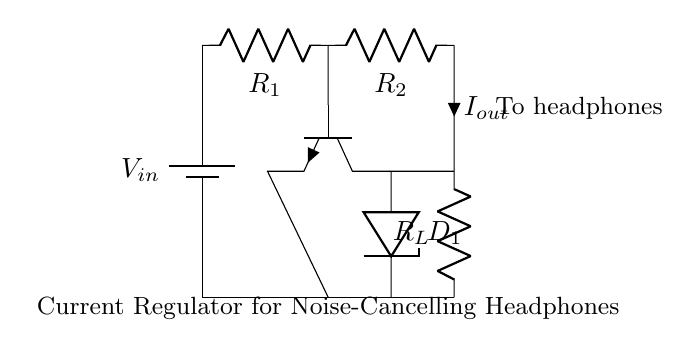What type of transistor is used in this circuit? The circuit contains an NPN transistor, as indicated by the symbol that represents a transistor with one arrow pointing out of the emitter, which is characteristic of NPN types.
Answer: NPN What is the function of the Zener diode in the circuit? The Zener diode is used to provide voltage regulation by maintaining a stable output voltage, effectively clamping the voltage to a certain level when the reverse bias exceeds the Zener breakdown voltage.
Answer: Voltage regulation How many resistors are in this circuit? There are three resistors labeled as R1, R2, and R_L in the circuit.
Answer: Three Where is the output current taken from? The output current, labeled as I_out, is taken from the connection between the load resistor R_L and the collector of the NPN transistor.
Answer: From R_L What is the purpose of the current regulator in noise-cancelling headphones? The current regulator ensures consistent current delivery to the headphones, which is vital for achieving stable sound quality and effective noise cancellation.
Answer: Consistent current delivery What connects the base of the NPN transistor to the circuit? The base of the NPN transistor is connected to the output of resistor R2, forming a pathway for base current that enables the transistor to control the collector-emitter current.
Answer: Resistor R2 